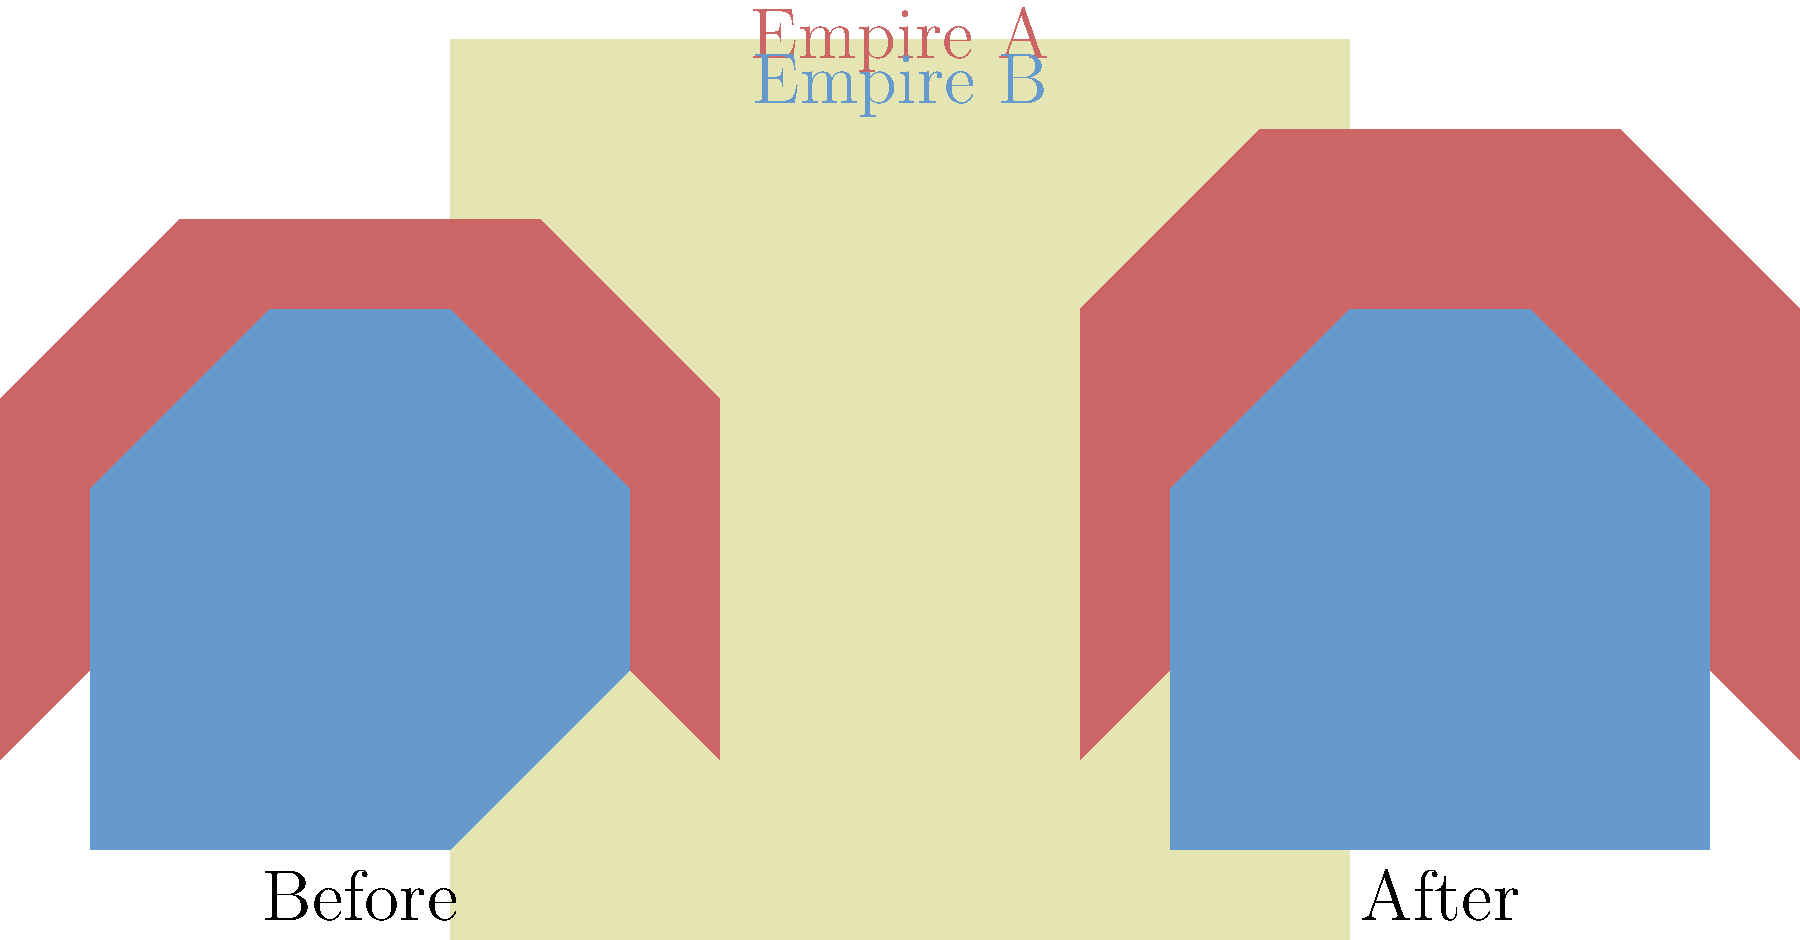Analyzing the before-and-after maps of two empires, what significant territorial change can be observed for Empire A (red), and how might this change impact its geopolitical position? To answer this question, we need to carefully examine the maps and compare the territories of Empire A (red) before and after the change:

1. Before the change:
   - Empire A's northern border extends to about 3 units on the y-axis.
   - Its territory is somewhat constrained by Empire B (blue) to the south.

2. After the change:
   - Empire A's northern border now extends to about 4 units on the y-axis.
   - It has gained significant territory in the north, pushing its border further upward.

3. Impact on geopolitical position:
   - The northward expansion gives Empire A access to new resources and potentially strategic locations.
   - It increases Empire A's total land area, which could translate to greater economic and military power.
   - The expansion puts pressure on any territories or rival powers that may exist to the north (not shown in the map).
   - Empire A now has a longer border to defend, which could be both an advantage and a challenge.

4. Relationship with Empire B:
   - The southern border with Empire B remains largely unchanged.
   - Empire B has lost some territory in the northeast to Empire A's expansion.

The most significant change is Empire A's northward expansion, gaining new territory and potentially improving its geopolitical position through increased resources and strategic depth.
Answer: Northward expansion, improving geopolitical position through increased territory and potential resources. 